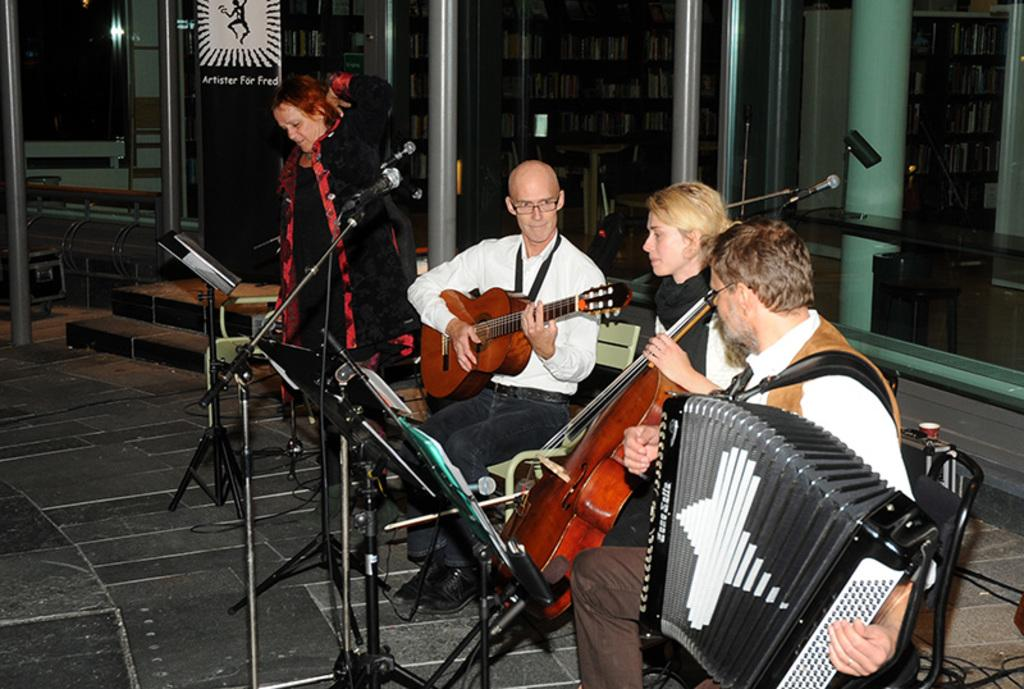How many people are in the image? There are four persons in the image. What are the persons doing in the image? The persons are playing musical instruments. What object is in front of the persons? There is a microphone in front of the persons. What can be seen in the background of the image? There is a building visible in the background of the image. What type of toy can be seen in the hands of the persons playing musical instruments? There is no toy present in the image; the persons are playing musical instruments. Is there any indication of a fight occurring in the image? No, there is no indication of a fight in the image; the persons are playing musical instruments and there is a microphone in front of them. 